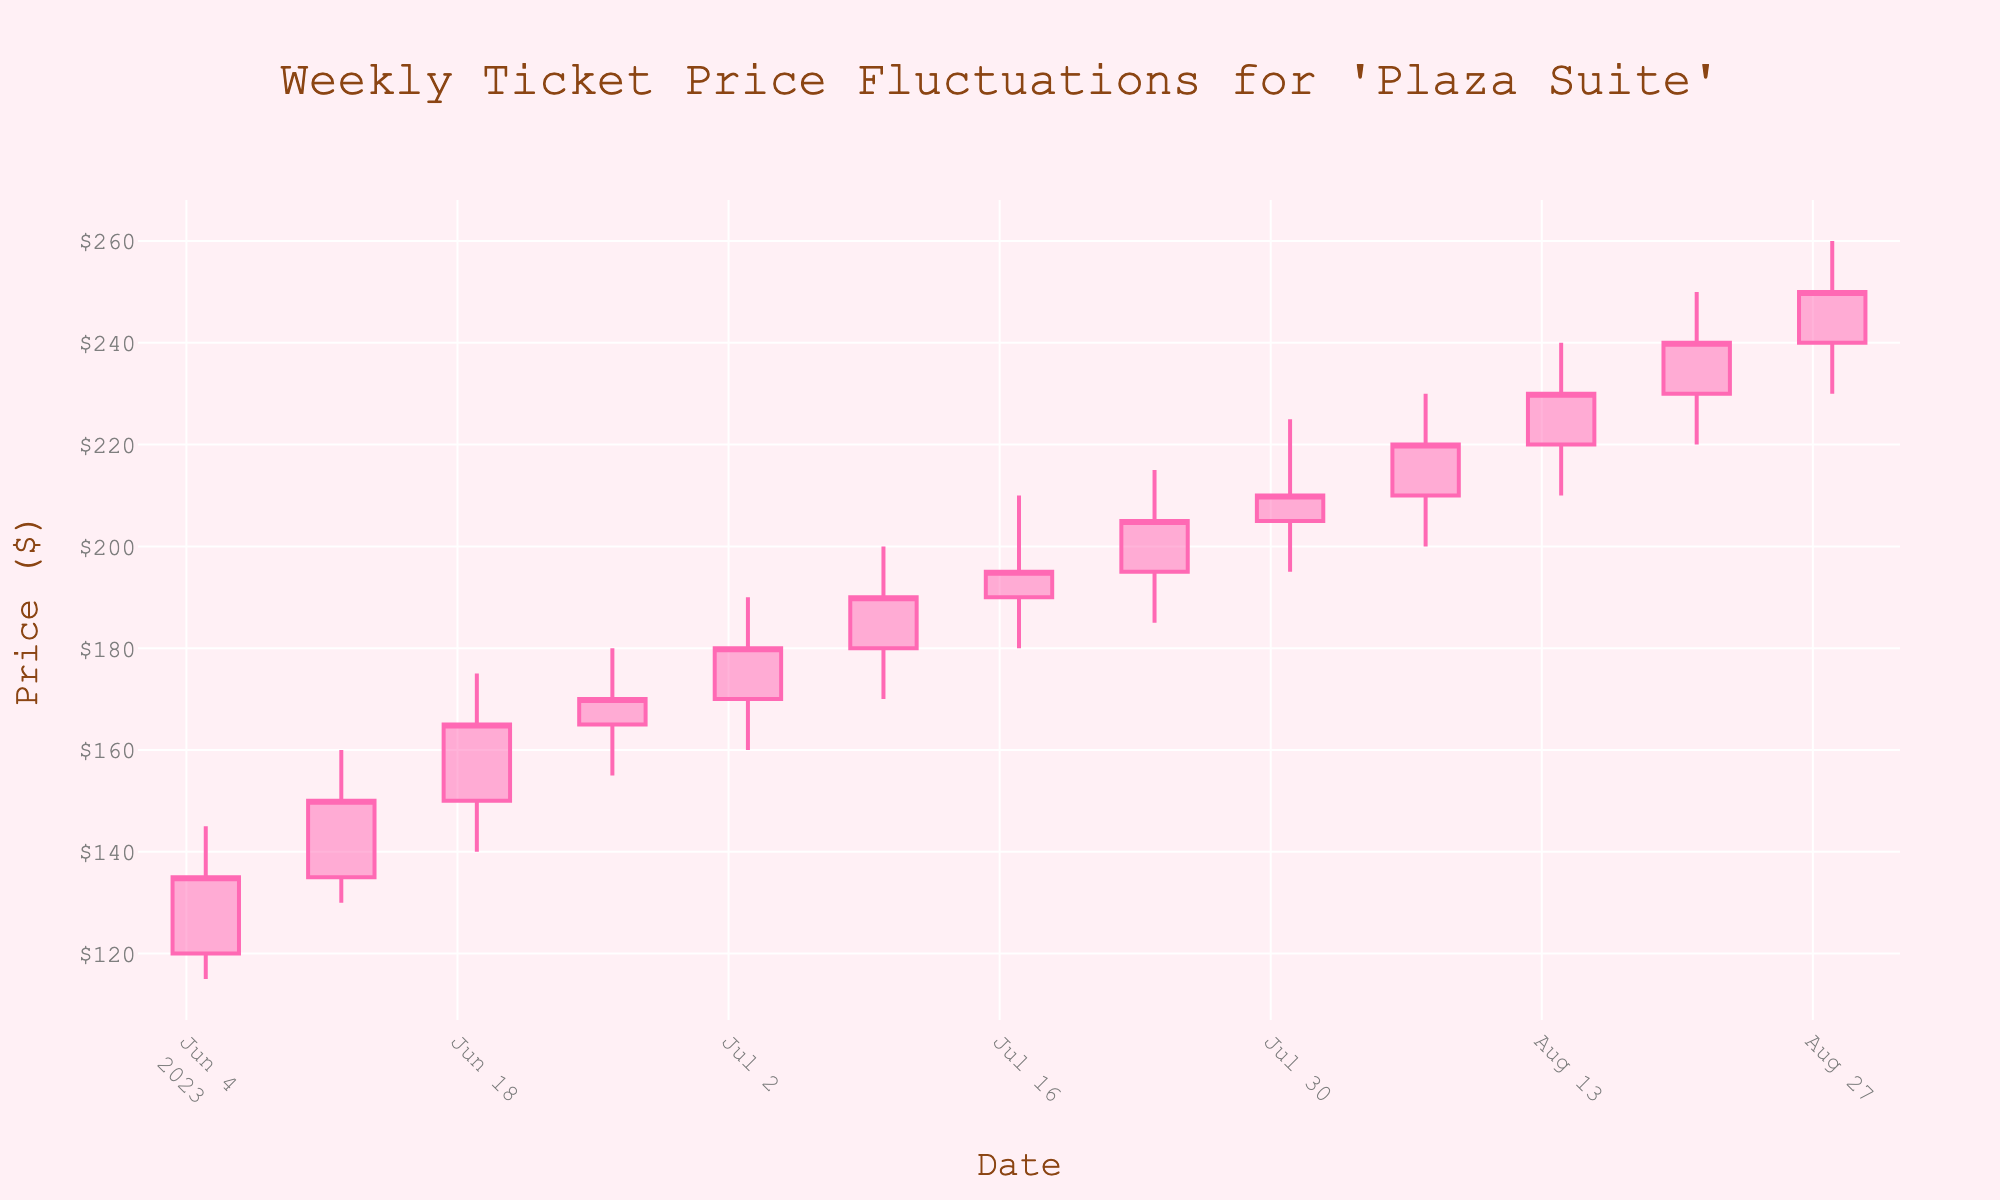What is the title of the chart? The title can be found on top of the chart, it reads "Weekly Ticket Price Fluctuations for 'Plaza Suite'"
Answer: Weekly Ticket Price Fluctuations for 'Plaza Suite' What is the color of the increasing line? The increasing line color can be observed within the candlestick chart, showing in hot pink when the closing price is higher than the opening price.
Answer: Hot Pink On which date did the ticket price close at the highest value? By looking at the closing prices across the chart, the highest closing price can be seen on 2023-08-28, which is $250.
Answer: 2023-08-28 What was the lowest ticket price recorded in July 2023? Checking the lowest prices within the month of July (from 2023-07-03 to 2023-07-31), the lowest recorded price was $160 on 2023-07-03.
Answer: $160 What is the average closing price for the month of June 2023? Summing the closing prices for June (135, 150, 165, 170) and dividing by the total number of weeks: (135 + 150 + 165 + 170) / 4 = 620 / 4 = 155.
Answer: $155 How many data points are represented on the chart? Each candlestick represents a week, and by counting these, there are 13 data points displayed.
Answer: 13 Which week showed the highest fluctuation within a single week, and what was the range? By examining the high-low range of each week, the week of 2023-08-28 displayed the highest fluctuation with a high of $260 and a low of $230, giving a range of (260 - 230) = $30.
Answer: 2023-08-28, $30 Comparing the opening prices, which week had the highest initial ticket price? By comparing the opening prices across the entire period, the highest opening price is seen on 2023-08-28 with an open price of $240.
Answer: 2023-08-28 What trend is indicated from June 2023 to August 2023 in the closing prices? Observing the closing prices from June 2023 starting at $135 to August 2023 ending at $250, there is a clear upward trend, indicating that the ticket prices are increasing over the period.
Answer: Upward trend 